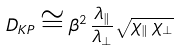<formula> <loc_0><loc_0><loc_500><loc_500>D _ { K P } \cong \beta ^ { 2 } \, \frac { \lambda _ { \| } } { \lambda _ { \bot } } \sqrt { \chi _ { \| } \, \chi _ { \bot } }</formula> 